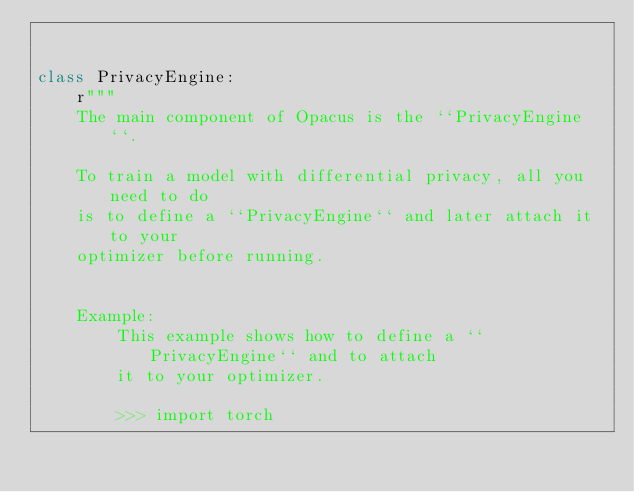Convert code to text. <code><loc_0><loc_0><loc_500><loc_500><_Python_>

class PrivacyEngine:
    r"""
    The main component of Opacus is the ``PrivacyEngine``.

    To train a model with differential privacy, all you need to do
    is to define a ``PrivacyEngine`` and later attach it to your
    optimizer before running.


    Example:
        This example shows how to define a ``PrivacyEngine`` and to attach
        it to your optimizer.

        >>> import torch</code> 